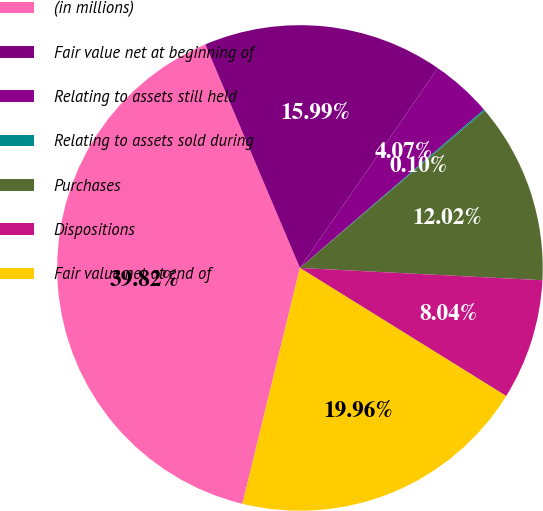Convert chart to OTSL. <chart><loc_0><loc_0><loc_500><loc_500><pie_chart><fcel>(in millions)<fcel>Fair value net at beginning of<fcel>Relating to assets still held<fcel>Relating to assets sold during<fcel>Purchases<fcel>Dispositions<fcel>Fair value net at end of<nl><fcel>39.82%<fcel>15.99%<fcel>4.07%<fcel>0.1%<fcel>12.02%<fcel>8.04%<fcel>19.96%<nl></chart> 